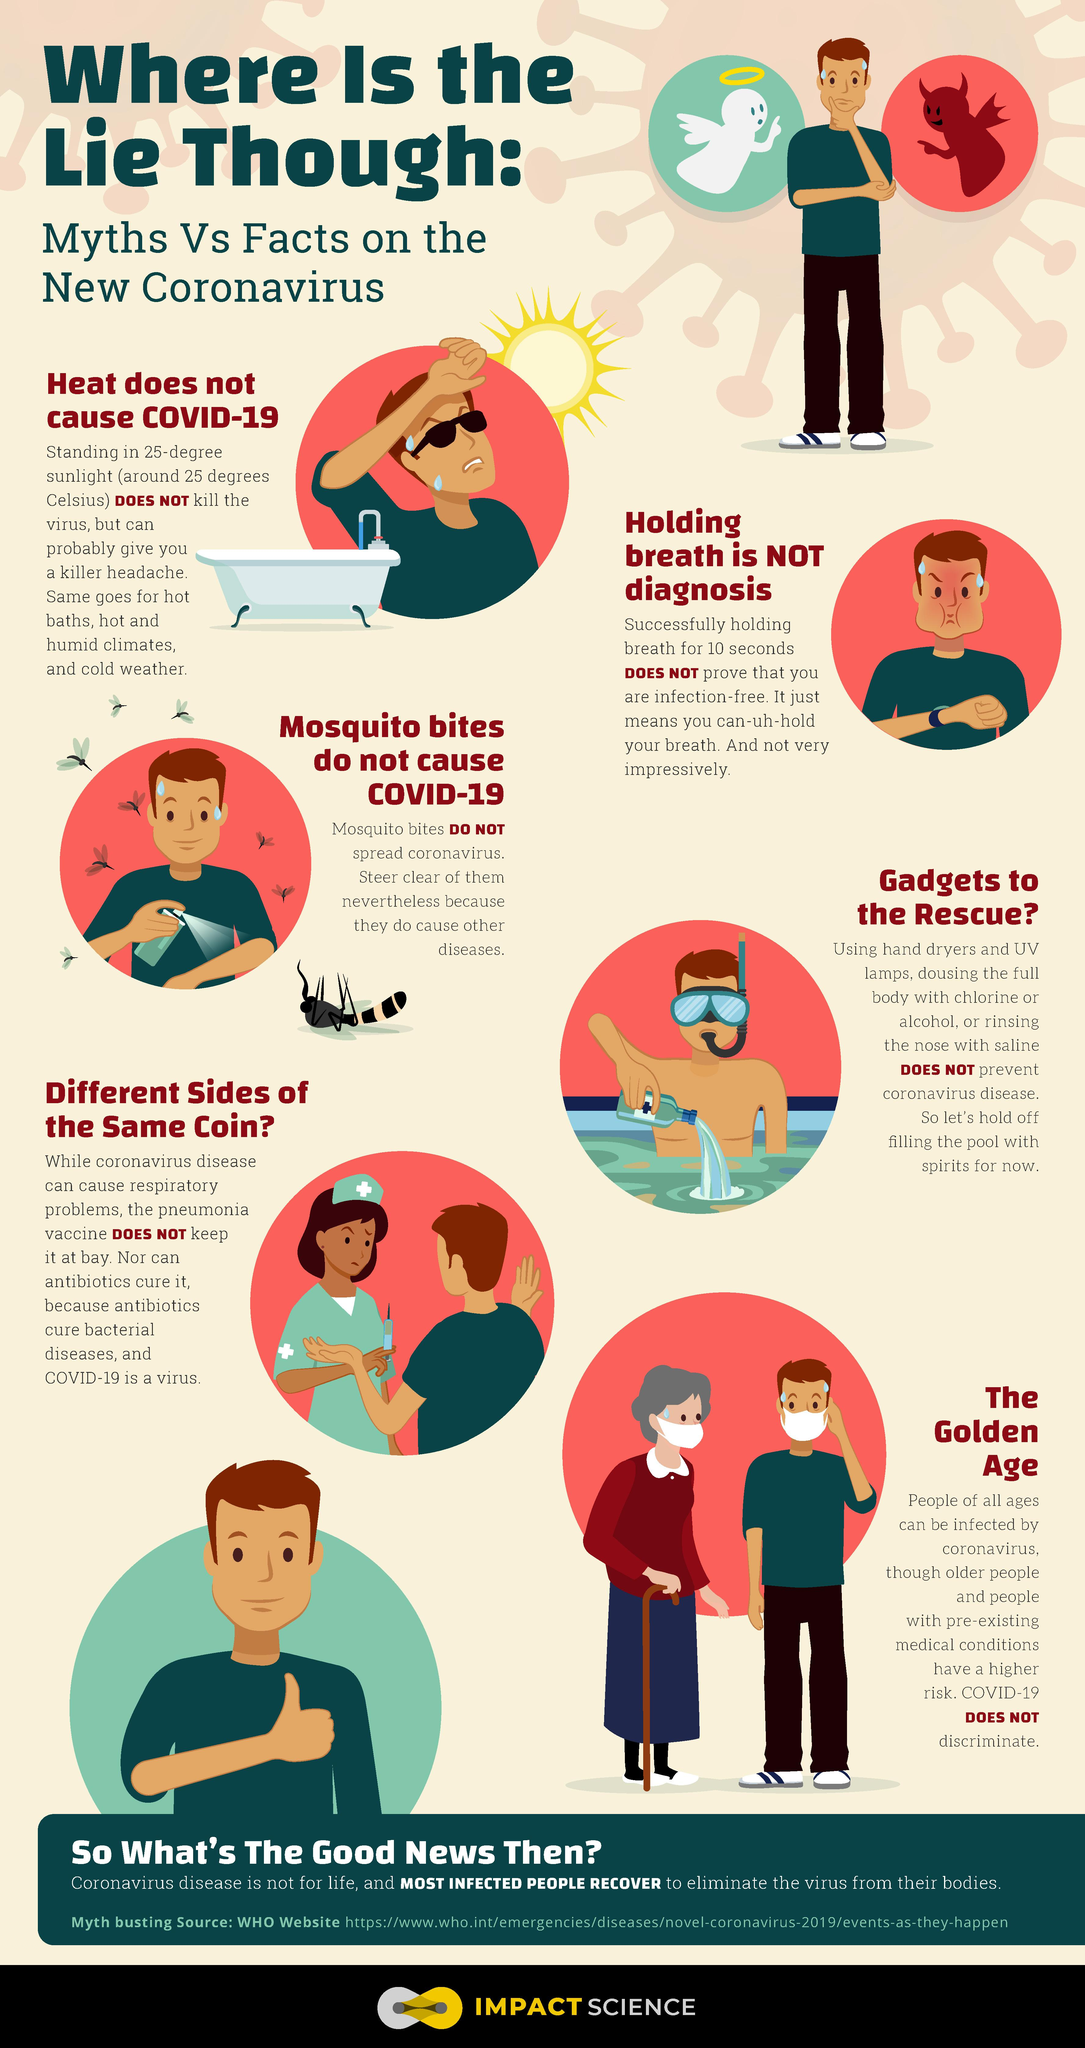Draw attention to some important aspects in this diagram. In this infographic, 2 individuals are depicted wearing masks. Antibiotics are medications that are effective in treating bacterial diseases. 